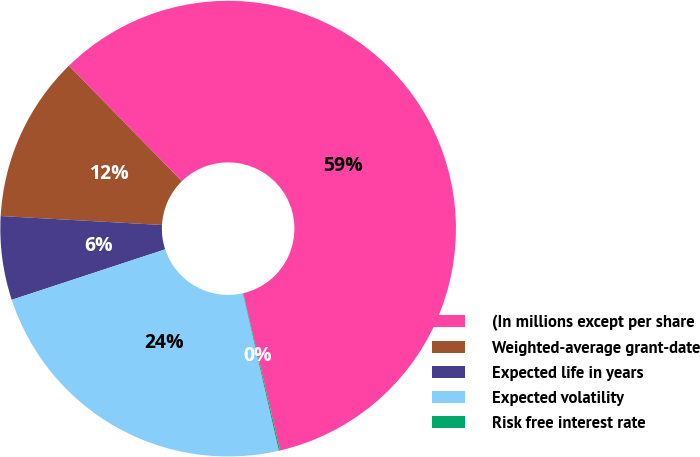Convert chart to OTSL. <chart><loc_0><loc_0><loc_500><loc_500><pie_chart><fcel>(In millions except per share<fcel>Weighted-average grant-date<fcel>Expected life in years<fcel>Expected volatility<fcel>Risk free interest rate<nl><fcel>58.65%<fcel>11.8%<fcel>5.94%<fcel>23.51%<fcel>0.09%<nl></chart> 